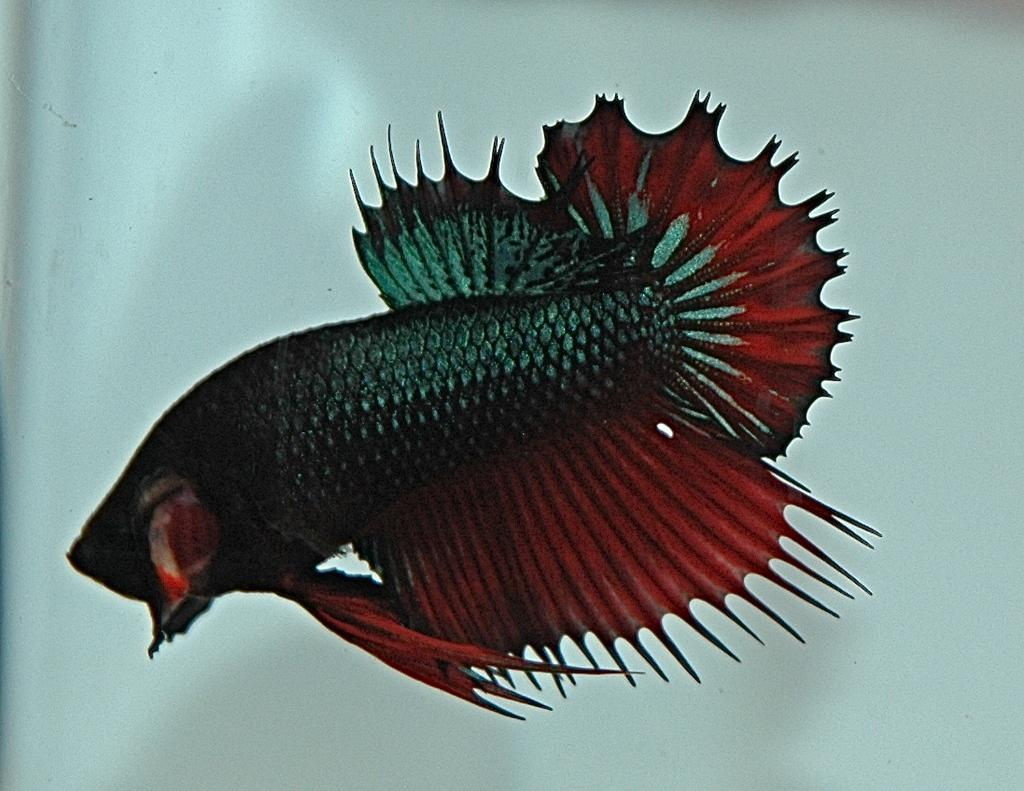What type of animal is in the image? There is a fish in the image. Where is the fish located? The fish is in water. What type of cream is being used to decorate the yam in the image? There is no yam or cream present in the image; it only features a fish in water. 